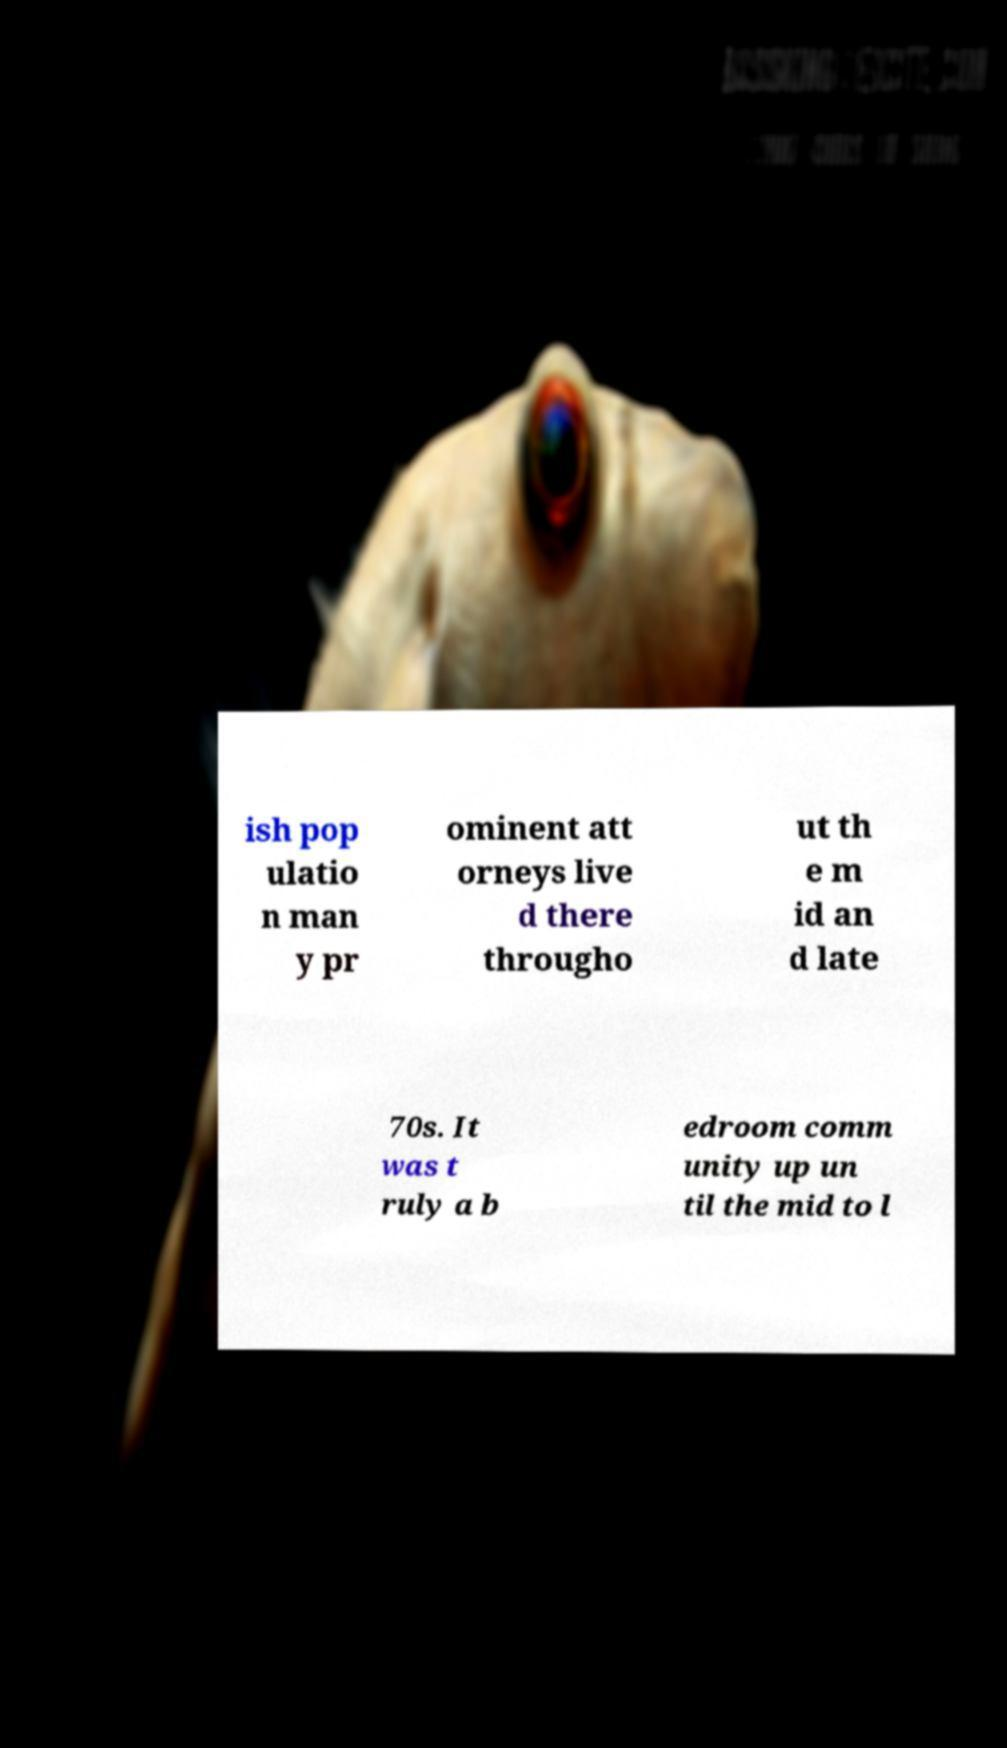For documentation purposes, I need the text within this image transcribed. Could you provide that? ish pop ulatio n man y pr ominent att orneys live d there througho ut th e m id an d late 70s. It was t ruly a b edroom comm unity up un til the mid to l 